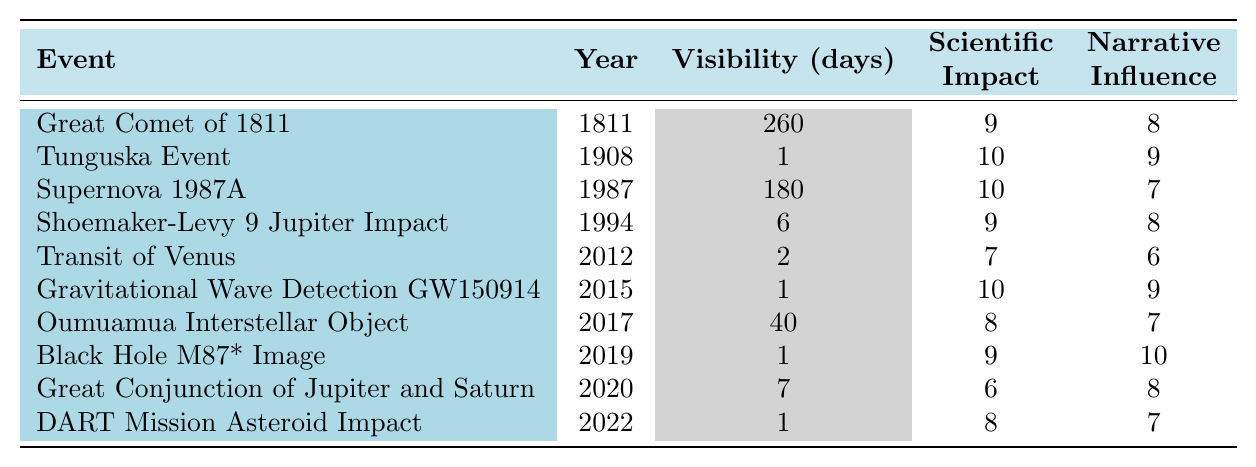What is the year of the Great Comet of 1811? The table lists the Great Comet of 1811 under the 'Event' column, and the corresponding 'Year' is specified next to it as 1811.
Answer: 1811 How many visibility days did the Supernova 1987A have? In the table, the visibility days for Supernova 1987A are presented in the corresponding column, which shows it as 180 days.
Answer: 180 Which event had the highest scientific impact rating and what was it? By examining the 'Scientific Impact' column for all events, I find that both the Tunguska Event and Supernova 1987A have a rating of 10, making them the highest rated events.
Answer: Tunguska Event and Supernova 1987A What is the average narrative influence of all events listed in the table? First, I sum the narrative influence values: (8 + 9 + 7 + 8 + 6 + 9 + 7 + 10 + 8 + 7) = 79. Then, I divide this sum by the total number of events, which is 10, giving me an average of 79/10 = 7.9.
Answer: 7.9 True or False: The DART Mission Asteroid Impact had a visibility of only one day. According to the table, the visibility days for the DART Mission Asteroid Impact are clearly indicated as 1 day. Therefore, the statement is true.
Answer: True Which event had the least visibility days? Looking at the 'Visibility (days)' column, I see that the Tunguska Event, Gravitational Wave Detection GW150914, Black Hole M87* Image, Great Conjunction of Jupiter and Saturn, and DART Mission Asteroid Impact all have a visibility of 1 day; however, Tunguska Event is listed first among these.
Answer: Tunguska Event What is the total scientific impact of events that had more than 100 visibility days? The only event with more than 100 visibility days is the Great Comet of 1811 with a scientific impact of 9. Thus, the total is 9.
Answer: 9 Identify the event with the lowest narrative influence score. By examining the 'Narrative Influence' column, I see that the 'Transit of Venus' has the lowest score at 6.
Answer: Transit of Venus Which event had a higher narrative influence: Oumuamua Interstellar Object or Shoemaker-Levy 9 Jupiter Impact? I compare their narrative influence scores: Oumuamua has 7 and Shoemaker-Levy 9 has 8. Since 8 is greater than 7, the Shoemaker-Levy 9 has a higher narrative influence.
Answer: Shoemaker-Levy 9 Jupiter Impact What is the difference in narrative influence between the Great Comet of 1811 and the Black Hole M87* Image? The Great Comet of 1811 has a narrative influence of 8, while the Black Hole M87* Image has a narrative influence of 10. The difference is 10 - 8 = 2.
Answer: 2 How many events had a scientific impact score of 9 or higher? By counting how many events meet the condition in the 'Scientific Impact' column, I find that there are 5 events with scores of 9 or higher: Great Comet of 1811, Tunguska Event, Supernova 1987A, Shoemaker-Levy 9, and Black Hole M87*.
Answer: 5 